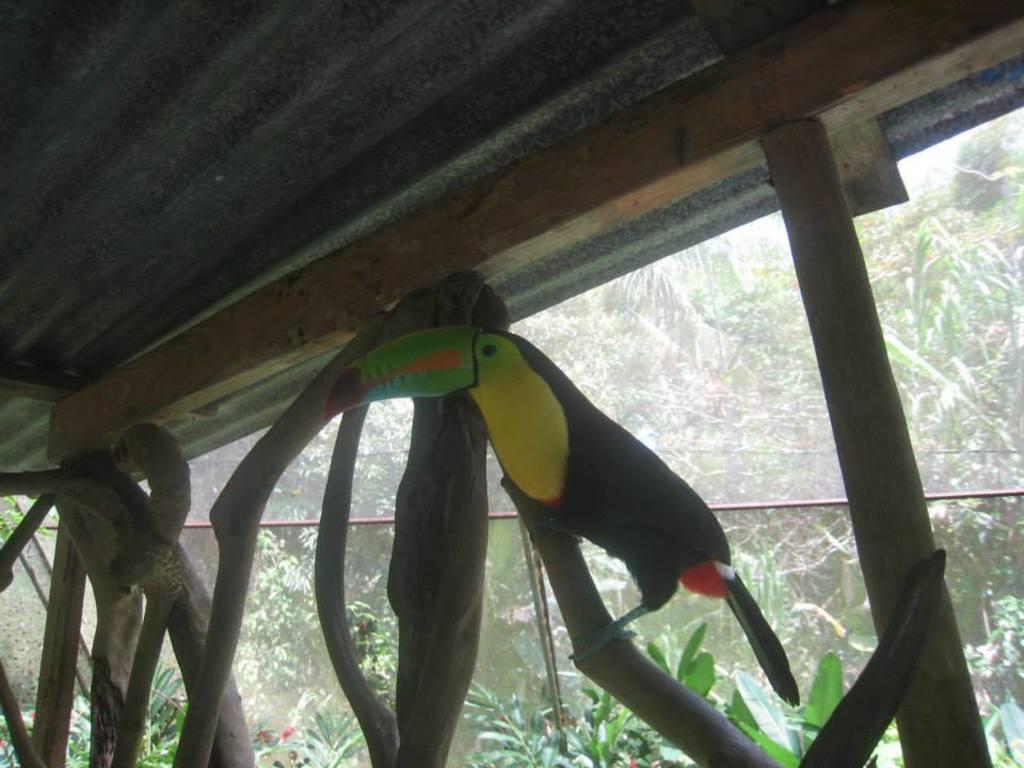Describe this image in one or two sentences. There is a bird on a wooden pole. There are many wooden poles. In the back there are many plants and trees. 